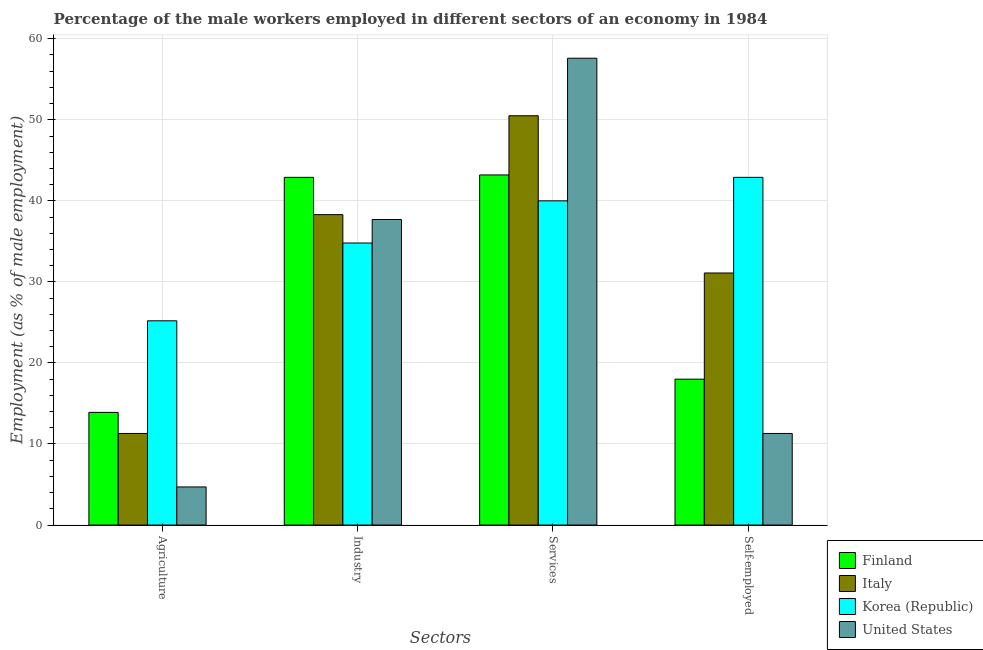How many groups of bars are there?
Keep it short and to the point. 4. Are the number of bars per tick equal to the number of legend labels?
Your answer should be very brief. Yes. How many bars are there on the 4th tick from the left?
Provide a succinct answer. 4. What is the label of the 1st group of bars from the left?
Provide a succinct answer. Agriculture. What is the percentage of male workers in services in United States?
Keep it short and to the point. 57.6. Across all countries, what is the maximum percentage of self employed male workers?
Offer a very short reply. 42.9. Across all countries, what is the minimum percentage of male workers in agriculture?
Offer a very short reply. 4.7. In which country was the percentage of male workers in agriculture minimum?
Make the answer very short. United States. What is the total percentage of self employed male workers in the graph?
Keep it short and to the point. 103.3. What is the difference between the percentage of self employed male workers in Korea (Republic) and that in Italy?
Keep it short and to the point. 11.8. What is the difference between the percentage of male workers in industry in Finland and the percentage of self employed male workers in United States?
Give a very brief answer. 31.6. What is the average percentage of male workers in agriculture per country?
Give a very brief answer. 13.78. What is the difference between the percentage of self employed male workers and percentage of male workers in agriculture in Finland?
Keep it short and to the point. 4.1. In how many countries, is the percentage of male workers in agriculture greater than 40 %?
Offer a very short reply. 0. What is the ratio of the percentage of male workers in agriculture in Korea (Republic) to that in Finland?
Offer a terse response. 1.81. What is the difference between the highest and the second highest percentage of male workers in industry?
Give a very brief answer. 4.6. What is the difference between the highest and the lowest percentage of male workers in industry?
Ensure brevity in your answer.  8.1. In how many countries, is the percentage of self employed male workers greater than the average percentage of self employed male workers taken over all countries?
Offer a very short reply. 2. What does the 2nd bar from the left in Industry represents?
Provide a succinct answer. Italy. What does the 3rd bar from the right in Self-employed represents?
Ensure brevity in your answer.  Italy. Is it the case that in every country, the sum of the percentage of male workers in agriculture and percentage of male workers in industry is greater than the percentage of male workers in services?
Offer a terse response. No. Does the graph contain any zero values?
Make the answer very short. No. How are the legend labels stacked?
Offer a terse response. Vertical. What is the title of the graph?
Your answer should be compact. Percentage of the male workers employed in different sectors of an economy in 1984. What is the label or title of the X-axis?
Provide a succinct answer. Sectors. What is the label or title of the Y-axis?
Keep it short and to the point. Employment (as % of male employment). What is the Employment (as % of male employment) of Finland in Agriculture?
Ensure brevity in your answer.  13.9. What is the Employment (as % of male employment) of Italy in Agriculture?
Keep it short and to the point. 11.3. What is the Employment (as % of male employment) in Korea (Republic) in Agriculture?
Your answer should be compact. 25.2. What is the Employment (as % of male employment) of United States in Agriculture?
Your answer should be very brief. 4.7. What is the Employment (as % of male employment) in Finland in Industry?
Give a very brief answer. 42.9. What is the Employment (as % of male employment) of Italy in Industry?
Your response must be concise. 38.3. What is the Employment (as % of male employment) in Korea (Republic) in Industry?
Keep it short and to the point. 34.8. What is the Employment (as % of male employment) of United States in Industry?
Give a very brief answer. 37.7. What is the Employment (as % of male employment) of Finland in Services?
Your response must be concise. 43.2. What is the Employment (as % of male employment) in Italy in Services?
Your response must be concise. 50.5. What is the Employment (as % of male employment) in United States in Services?
Provide a short and direct response. 57.6. What is the Employment (as % of male employment) of Italy in Self-employed?
Offer a very short reply. 31.1. What is the Employment (as % of male employment) of Korea (Republic) in Self-employed?
Your response must be concise. 42.9. What is the Employment (as % of male employment) in United States in Self-employed?
Your answer should be very brief. 11.3. Across all Sectors, what is the maximum Employment (as % of male employment) in Finland?
Make the answer very short. 43.2. Across all Sectors, what is the maximum Employment (as % of male employment) in Italy?
Your response must be concise. 50.5. Across all Sectors, what is the maximum Employment (as % of male employment) of Korea (Republic)?
Provide a short and direct response. 42.9. Across all Sectors, what is the maximum Employment (as % of male employment) of United States?
Give a very brief answer. 57.6. Across all Sectors, what is the minimum Employment (as % of male employment) of Finland?
Your response must be concise. 13.9. Across all Sectors, what is the minimum Employment (as % of male employment) of Italy?
Offer a very short reply. 11.3. Across all Sectors, what is the minimum Employment (as % of male employment) of Korea (Republic)?
Your answer should be compact. 25.2. Across all Sectors, what is the minimum Employment (as % of male employment) of United States?
Give a very brief answer. 4.7. What is the total Employment (as % of male employment) of Finland in the graph?
Your response must be concise. 118. What is the total Employment (as % of male employment) in Italy in the graph?
Your response must be concise. 131.2. What is the total Employment (as % of male employment) in Korea (Republic) in the graph?
Offer a very short reply. 142.9. What is the total Employment (as % of male employment) of United States in the graph?
Your answer should be compact. 111.3. What is the difference between the Employment (as % of male employment) in Finland in Agriculture and that in Industry?
Your answer should be very brief. -29. What is the difference between the Employment (as % of male employment) of Italy in Agriculture and that in Industry?
Provide a succinct answer. -27. What is the difference between the Employment (as % of male employment) in United States in Agriculture and that in Industry?
Provide a short and direct response. -33. What is the difference between the Employment (as % of male employment) in Finland in Agriculture and that in Services?
Your answer should be compact. -29.3. What is the difference between the Employment (as % of male employment) in Italy in Agriculture and that in Services?
Give a very brief answer. -39.2. What is the difference between the Employment (as % of male employment) of Korea (Republic) in Agriculture and that in Services?
Keep it short and to the point. -14.8. What is the difference between the Employment (as % of male employment) of United States in Agriculture and that in Services?
Offer a terse response. -52.9. What is the difference between the Employment (as % of male employment) in Italy in Agriculture and that in Self-employed?
Provide a succinct answer. -19.8. What is the difference between the Employment (as % of male employment) in Korea (Republic) in Agriculture and that in Self-employed?
Offer a very short reply. -17.7. What is the difference between the Employment (as % of male employment) of Finland in Industry and that in Services?
Provide a succinct answer. -0.3. What is the difference between the Employment (as % of male employment) in Korea (Republic) in Industry and that in Services?
Offer a terse response. -5.2. What is the difference between the Employment (as % of male employment) in United States in Industry and that in Services?
Provide a short and direct response. -19.9. What is the difference between the Employment (as % of male employment) in Finland in Industry and that in Self-employed?
Your answer should be compact. 24.9. What is the difference between the Employment (as % of male employment) in Korea (Republic) in Industry and that in Self-employed?
Provide a short and direct response. -8.1. What is the difference between the Employment (as % of male employment) in United States in Industry and that in Self-employed?
Provide a succinct answer. 26.4. What is the difference between the Employment (as % of male employment) of Finland in Services and that in Self-employed?
Ensure brevity in your answer.  25.2. What is the difference between the Employment (as % of male employment) in Italy in Services and that in Self-employed?
Give a very brief answer. 19.4. What is the difference between the Employment (as % of male employment) of United States in Services and that in Self-employed?
Ensure brevity in your answer.  46.3. What is the difference between the Employment (as % of male employment) in Finland in Agriculture and the Employment (as % of male employment) in Italy in Industry?
Ensure brevity in your answer.  -24.4. What is the difference between the Employment (as % of male employment) in Finland in Agriculture and the Employment (as % of male employment) in Korea (Republic) in Industry?
Provide a short and direct response. -20.9. What is the difference between the Employment (as % of male employment) of Finland in Agriculture and the Employment (as % of male employment) of United States in Industry?
Offer a terse response. -23.8. What is the difference between the Employment (as % of male employment) in Italy in Agriculture and the Employment (as % of male employment) in Korea (Republic) in Industry?
Your answer should be very brief. -23.5. What is the difference between the Employment (as % of male employment) of Italy in Agriculture and the Employment (as % of male employment) of United States in Industry?
Offer a very short reply. -26.4. What is the difference between the Employment (as % of male employment) in Korea (Republic) in Agriculture and the Employment (as % of male employment) in United States in Industry?
Your response must be concise. -12.5. What is the difference between the Employment (as % of male employment) in Finland in Agriculture and the Employment (as % of male employment) in Italy in Services?
Offer a terse response. -36.6. What is the difference between the Employment (as % of male employment) in Finland in Agriculture and the Employment (as % of male employment) in Korea (Republic) in Services?
Keep it short and to the point. -26.1. What is the difference between the Employment (as % of male employment) of Finland in Agriculture and the Employment (as % of male employment) of United States in Services?
Give a very brief answer. -43.7. What is the difference between the Employment (as % of male employment) of Italy in Agriculture and the Employment (as % of male employment) of Korea (Republic) in Services?
Offer a very short reply. -28.7. What is the difference between the Employment (as % of male employment) in Italy in Agriculture and the Employment (as % of male employment) in United States in Services?
Ensure brevity in your answer.  -46.3. What is the difference between the Employment (as % of male employment) in Korea (Republic) in Agriculture and the Employment (as % of male employment) in United States in Services?
Make the answer very short. -32.4. What is the difference between the Employment (as % of male employment) in Finland in Agriculture and the Employment (as % of male employment) in Italy in Self-employed?
Provide a succinct answer. -17.2. What is the difference between the Employment (as % of male employment) in Italy in Agriculture and the Employment (as % of male employment) in Korea (Republic) in Self-employed?
Ensure brevity in your answer.  -31.6. What is the difference between the Employment (as % of male employment) of Italy in Agriculture and the Employment (as % of male employment) of United States in Self-employed?
Give a very brief answer. 0. What is the difference between the Employment (as % of male employment) of Korea (Republic) in Agriculture and the Employment (as % of male employment) of United States in Self-employed?
Give a very brief answer. 13.9. What is the difference between the Employment (as % of male employment) in Finland in Industry and the Employment (as % of male employment) in Italy in Services?
Your answer should be very brief. -7.6. What is the difference between the Employment (as % of male employment) in Finland in Industry and the Employment (as % of male employment) in United States in Services?
Your answer should be very brief. -14.7. What is the difference between the Employment (as % of male employment) in Italy in Industry and the Employment (as % of male employment) in United States in Services?
Offer a terse response. -19.3. What is the difference between the Employment (as % of male employment) of Korea (Republic) in Industry and the Employment (as % of male employment) of United States in Services?
Make the answer very short. -22.8. What is the difference between the Employment (as % of male employment) of Finland in Industry and the Employment (as % of male employment) of Italy in Self-employed?
Offer a terse response. 11.8. What is the difference between the Employment (as % of male employment) of Finland in Industry and the Employment (as % of male employment) of Korea (Republic) in Self-employed?
Offer a terse response. 0. What is the difference between the Employment (as % of male employment) in Finland in Industry and the Employment (as % of male employment) in United States in Self-employed?
Offer a terse response. 31.6. What is the difference between the Employment (as % of male employment) of Italy in Industry and the Employment (as % of male employment) of United States in Self-employed?
Provide a short and direct response. 27. What is the difference between the Employment (as % of male employment) in Korea (Republic) in Industry and the Employment (as % of male employment) in United States in Self-employed?
Your answer should be compact. 23.5. What is the difference between the Employment (as % of male employment) of Finland in Services and the Employment (as % of male employment) of Korea (Republic) in Self-employed?
Keep it short and to the point. 0.3. What is the difference between the Employment (as % of male employment) in Finland in Services and the Employment (as % of male employment) in United States in Self-employed?
Provide a succinct answer. 31.9. What is the difference between the Employment (as % of male employment) of Italy in Services and the Employment (as % of male employment) of United States in Self-employed?
Provide a short and direct response. 39.2. What is the difference between the Employment (as % of male employment) in Korea (Republic) in Services and the Employment (as % of male employment) in United States in Self-employed?
Give a very brief answer. 28.7. What is the average Employment (as % of male employment) in Finland per Sectors?
Provide a short and direct response. 29.5. What is the average Employment (as % of male employment) in Italy per Sectors?
Provide a short and direct response. 32.8. What is the average Employment (as % of male employment) in Korea (Republic) per Sectors?
Your response must be concise. 35.73. What is the average Employment (as % of male employment) of United States per Sectors?
Offer a terse response. 27.82. What is the difference between the Employment (as % of male employment) in Finland and Employment (as % of male employment) in Italy in Agriculture?
Your response must be concise. 2.6. What is the difference between the Employment (as % of male employment) of Finland and Employment (as % of male employment) of Korea (Republic) in Agriculture?
Give a very brief answer. -11.3. What is the difference between the Employment (as % of male employment) of Korea (Republic) and Employment (as % of male employment) of United States in Agriculture?
Your response must be concise. 20.5. What is the difference between the Employment (as % of male employment) of Finland and Employment (as % of male employment) of Italy in Industry?
Make the answer very short. 4.6. What is the difference between the Employment (as % of male employment) of Finland and Employment (as % of male employment) of United States in Industry?
Your response must be concise. 5.2. What is the difference between the Employment (as % of male employment) of Italy and Employment (as % of male employment) of United States in Industry?
Make the answer very short. 0.6. What is the difference between the Employment (as % of male employment) of Finland and Employment (as % of male employment) of United States in Services?
Keep it short and to the point. -14.4. What is the difference between the Employment (as % of male employment) in Italy and Employment (as % of male employment) in Korea (Republic) in Services?
Offer a terse response. 10.5. What is the difference between the Employment (as % of male employment) of Korea (Republic) and Employment (as % of male employment) of United States in Services?
Provide a succinct answer. -17.6. What is the difference between the Employment (as % of male employment) in Finland and Employment (as % of male employment) in Korea (Republic) in Self-employed?
Provide a short and direct response. -24.9. What is the difference between the Employment (as % of male employment) of Finland and Employment (as % of male employment) of United States in Self-employed?
Your answer should be compact. 6.7. What is the difference between the Employment (as % of male employment) of Italy and Employment (as % of male employment) of United States in Self-employed?
Offer a terse response. 19.8. What is the difference between the Employment (as % of male employment) in Korea (Republic) and Employment (as % of male employment) in United States in Self-employed?
Your answer should be compact. 31.6. What is the ratio of the Employment (as % of male employment) of Finland in Agriculture to that in Industry?
Your response must be concise. 0.32. What is the ratio of the Employment (as % of male employment) in Italy in Agriculture to that in Industry?
Offer a very short reply. 0.29. What is the ratio of the Employment (as % of male employment) in Korea (Republic) in Agriculture to that in Industry?
Give a very brief answer. 0.72. What is the ratio of the Employment (as % of male employment) of United States in Agriculture to that in Industry?
Keep it short and to the point. 0.12. What is the ratio of the Employment (as % of male employment) in Finland in Agriculture to that in Services?
Offer a very short reply. 0.32. What is the ratio of the Employment (as % of male employment) of Italy in Agriculture to that in Services?
Provide a succinct answer. 0.22. What is the ratio of the Employment (as % of male employment) in Korea (Republic) in Agriculture to that in Services?
Make the answer very short. 0.63. What is the ratio of the Employment (as % of male employment) of United States in Agriculture to that in Services?
Keep it short and to the point. 0.08. What is the ratio of the Employment (as % of male employment) of Finland in Agriculture to that in Self-employed?
Keep it short and to the point. 0.77. What is the ratio of the Employment (as % of male employment) in Italy in Agriculture to that in Self-employed?
Your response must be concise. 0.36. What is the ratio of the Employment (as % of male employment) in Korea (Republic) in Agriculture to that in Self-employed?
Ensure brevity in your answer.  0.59. What is the ratio of the Employment (as % of male employment) in United States in Agriculture to that in Self-employed?
Make the answer very short. 0.42. What is the ratio of the Employment (as % of male employment) of Finland in Industry to that in Services?
Your answer should be compact. 0.99. What is the ratio of the Employment (as % of male employment) of Italy in Industry to that in Services?
Give a very brief answer. 0.76. What is the ratio of the Employment (as % of male employment) of Korea (Republic) in Industry to that in Services?
Give a very brief answer. 0.87. What is the ratio of the Employment (as % of male employment) in United States in Industry to that in Services?
Offer a terse response. 0.65. What is the ratio of the Employment (as % of male employment) in Finland in Industry to that in Self-employed?
Your response must be concise. 2.38. What is the ratio of the Employment (as % of male employment) of Italy in Industry to that in Self-employed?
Offer a terse response. 1.23. What is the ratio of the Employment (as % of male employment) of Korea (Republic) in Industry to that in Self-employed?
Your answer should be very brief. 0.81. What is the ratio of the Employment (as % of male employment) of United States in Industry to that in Self-employed?
Your response must be concise. 3.34. What is the ratio of the Employment (as % of male employment) of Finland in Services to that in Self-employed?
Keep it short and to the point. 2.4. What is the ratio of the Employment (as % of male employment) of Italy in Services to that in Self-employed?
Your answer should be very brief. 1.62. What is the ratio of the Employment (as % of male employment) in Korea (Republic) in Services to that in Self-employed?
Your answer should be very brief. 0.93. What is the ratio of the Employment (as % of male employment) in United States in Services to that in Self-employed?
Ensure brevity in your answer.  5.1. What is the difference between the highest and the second highest Employment (as % of male employment) of Finland?
Give a very brief answer. 0.3. What is the difference between the highest and the lowest Employment (as % of male employment) of Finland?
Keep it short and to the point. 29.3. What is the difference between the highest and the lowest Employment (as % of male employment) of Italy?
Provide a succinct answer. 39.2. What is the difference between the highest and the lowest Employment (as % of male employment) of Korea (Republic)?
Keep it short and to the point. 17.7. What is the difference between the highest and the lowest Employment (as % of male employment) of United States?
Provide a succinct answer. 52.9. 